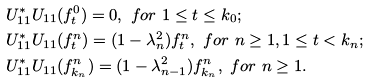Convert formula to latex. <formula><loc_0><loc_0><loc_500><loc_500>& U _ { 1 1 } ^ { * } U _ { 1 1 } ( f ^ { 0 } _ { t } ) = 0 , \ f o r \ 1 \leq t \leq k _ { 0 } ; \\ & U _ { 1 1 } ^ { * } U _ { 1 1 } ( f ^ { n } _ { t } ) = ( 1 - \lambda _ { n } ^ { 2 } ) f ^ { n } _ { t } , \ f o r \ n \geq 1 , 1 \leq t < k _ { n } ; \\ & U _ { 1 1 } ^ { * } U _ { 1 1 } ( f ^ { n } _ { k _ { n } } ) = ( 1 - \lambda _ { n - 1 } ^ { 2 } ) f ^ { n } _ { k _ { n } } , \ f o r \ n \geq 1 .</formula> 